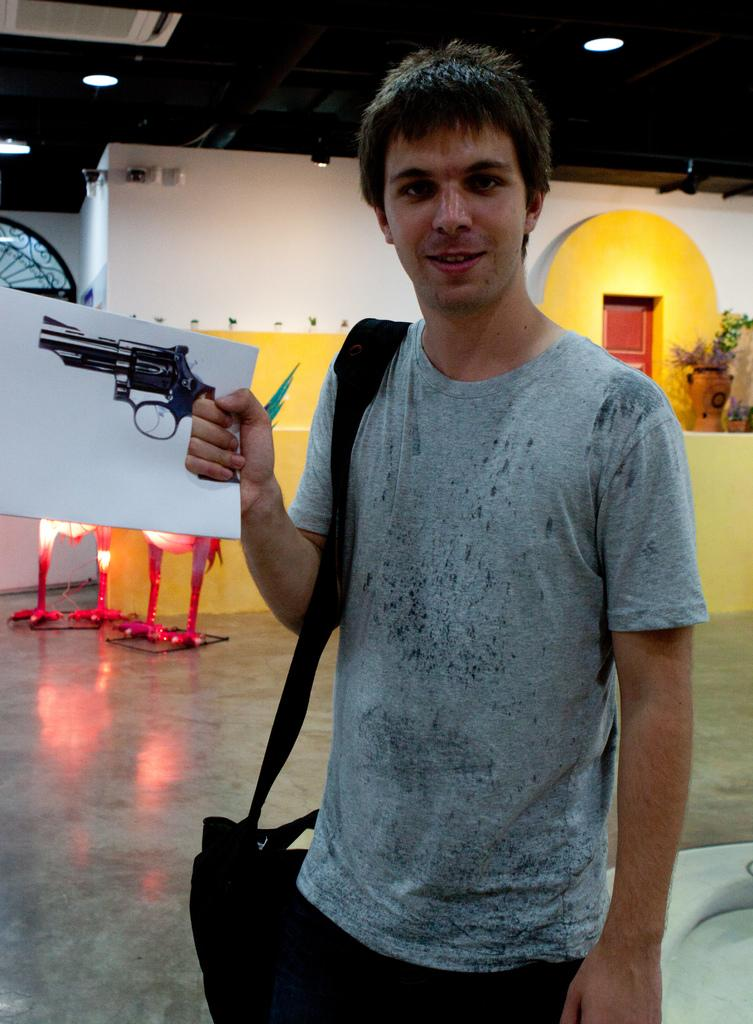What is the main subject of the image? There is a person in the image. What is the person doing in the image? The person is standing. What is the person holding in the image? The person is holding a paper. What color is the bag the person is wearing? The person is wearing a black color bag. What color is the shirt the person is wearing? The person is wearing a gray color shirt. What color are the pants the person is wearing? The person is wearing black pants. What can be seen in the background of the image? There is a wall in the background of the image. What colors are the wall in the background? The wall is white and yellow. Are there any cobwebs visible on the person's clothing in the image? There are no cobwebs visible on the person's clothing in the image. What class is the person attending in the image? There is no indication of a class or any educational setting in the image. 